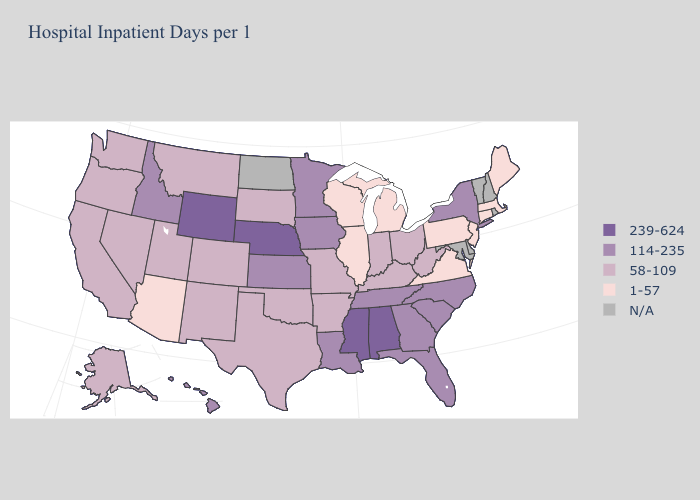Which states have the lowest value in the MidWest?
Write a very short answer. Illinois, Michigan, Wisconsin. Name the states that have a value in the range 1-57?
Quick response, please. Arizona, Connecticut, Illinois, Maine, Massachusetts, Michigan, New Jersey, Pennsylvania, Virginia, Wisconsin. What is the lowest value in states that border Tennessee?
Short answer required. 1-57. Does Arizona have the lowest value in the West?
Be succinct. Yes. What is the lowest value in states that border Indiana?
Write a very short answer. 1-57. What is the value of California?
Short answer required. 58-109. Name the states that have a value in the range N/A?
Quick response, please. Delaware, Maryland, New Hampshire, North Dakota, Rhode Island, Vermont. Which states hav the highest value in the MidWest?
Write a very short answer. Nebraska. Name the states that have a value in the range 239-624?
Answer briefly. Alabama, Mississippi, Nebraska, Wyoming. Name the states that have a value in the range 58-109?
Give a very brief answer. Alaska, Arkansas, California, Colorado, Indiana, Kentucky, Missouri, Montana, Nevada, New Mexico, Ohio, Oklahoma, Oregon, South Dakota, Texas, Utah, Washington, West Virginia. What is the highest value in the MidWest ?
Keep it brief. 239-624. What is the value of Missouri?
Give a very brief answer. 58-109. 